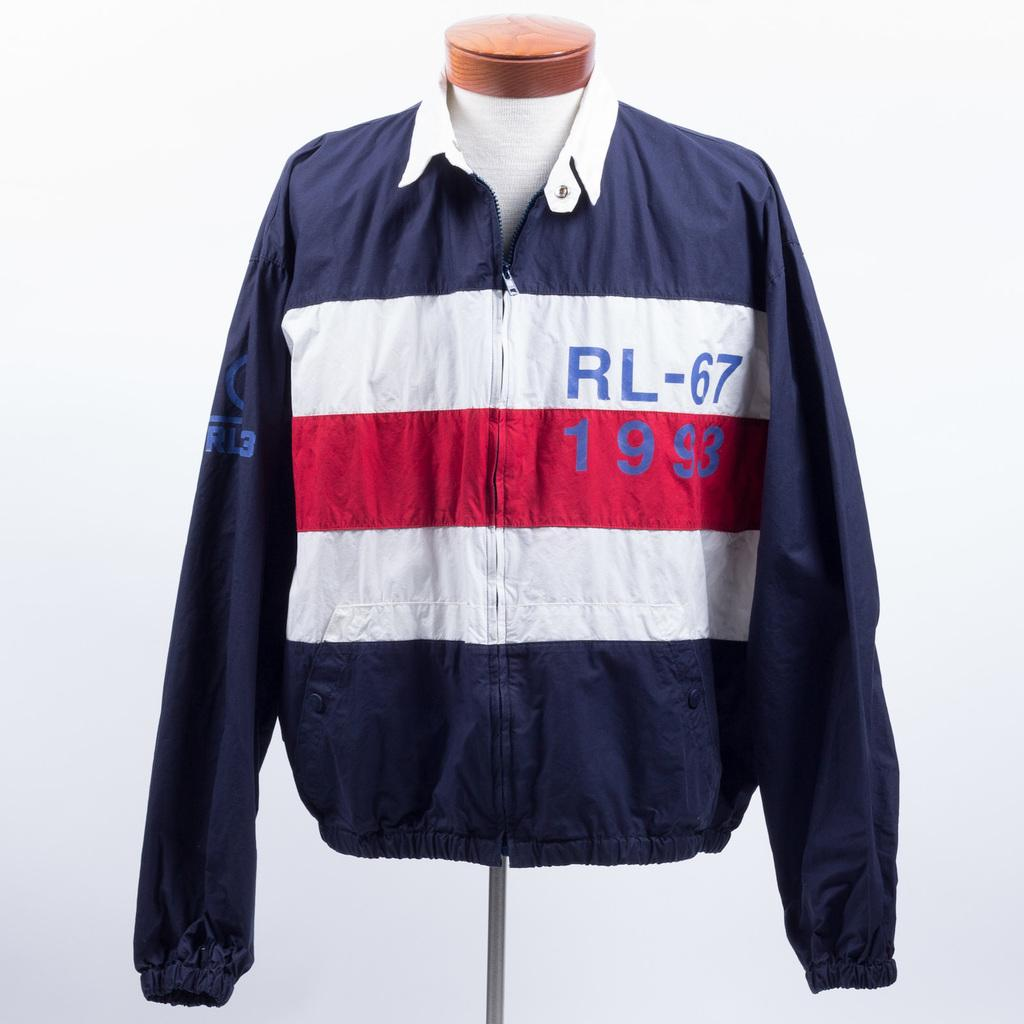<image>
Write a terse but informative summary of the picture. dark blue jacket with white and red stripes and lettering RL-67 1993 